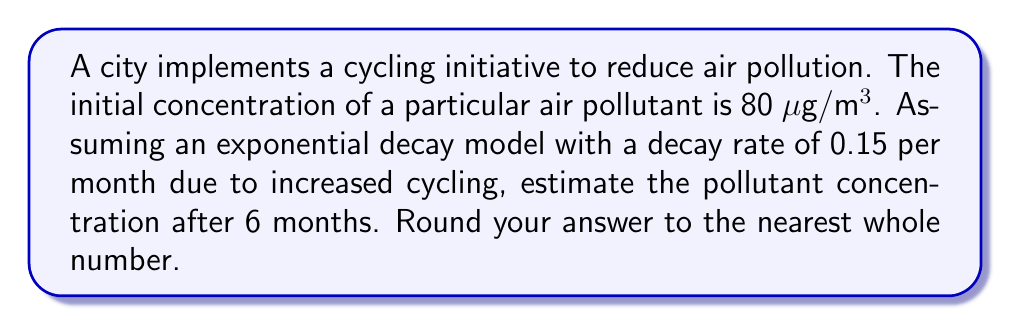Can you answer this question? To solve this problem, we'll use the exponential decay model:

$$C(t) = C_0 e^{-kt}$$

Where:
$C(t)$ is the concentration at time $t$
$C_0$ is the initial concentration
$k$ is the decay rate
$t$ is the time

Given:
$C_0 = 80$ μg/m³
$k = 0.15$ per month
$t = 6$ months

Step 1: Substitute the values into the equation:
$$C(6) = 80 e^{-0.15 \cdot 6}$$

Step 2: Simplify the exponent:
$$C(6) = 80 e^{-0.9}$$

Step 3: Calculate the value of $e^{-0.9}$:
$$e^{-0.9} \approx 0.4066$$

Step 4: Multiply by the initial concentration:
$$C(6) = 80 \cdot 0.4066 \approx 32.528$$

Step 5: Round to the nearest whole number:
$$C(6) \approx 33$$ μg/m³
Answer: 33 μg/m³ 